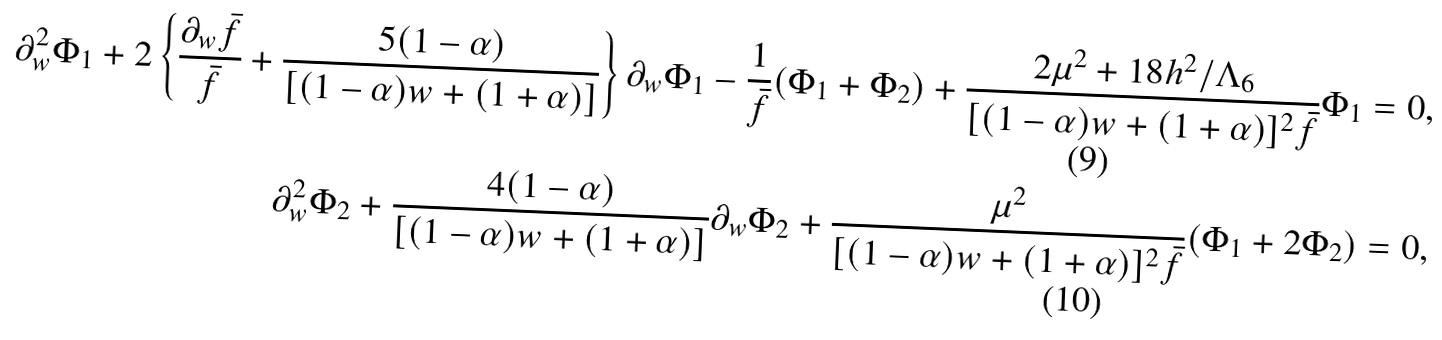<formula> <loc_0><loc_0><loc_500><loc_500>\partial _ { w } ^ { 2 } \Phi _ { 1 } + 2 \left \{ \frac { \partial _ { w } \bar { f } } { \bar { f } } + \frac { 5 ( 1 - \alpha ) } { [ ( 1 - \alpha ) w + ( 1 + \alpha ) ] } \right \} \partial _ { w } \Phi _ { 1 } - \frac { 1 } { \bar { f } } ( \Phi _ { 1 } + \Phi _ { 2 } ) + \frac { 2 \mu ^ { 2 } + 1 8 h ^ { 2 } / \Lambda _ { 6 } } { [ ( 1 - \alpha ) w + ( 1 + \alpha ) ] ^ { 2 } \bar { f } } \Phi _ { 1 } & = 0 , \\ \partial _ { w } ^ { 2 } \Phi _ { 2 } + \frac { 4 ( 1 - \alpha ) } { [ ( 1 - \alpha ) w + ( 1 + \alpha ) ] } \partial _ { w } \Phi _ { 2 } + \frac { \mu ^ { 2 } } { [ ( 1 - \alpha ) w + ( 1 + \alpha ) ] ^ { 2 } \bar { f } } ( \Phi _ { 1 } + 2 \Phi _ { 2 } ) & = 0 ,</formula> 